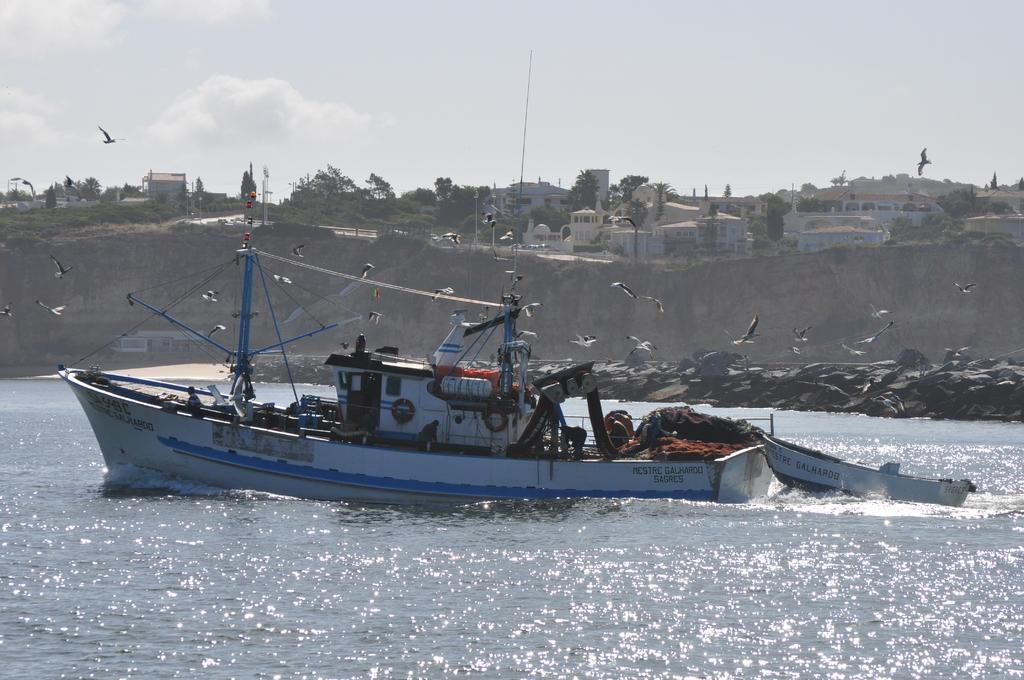Can you describe this image briefly? This image is taken outdoors. At the top of the image there is the sky with clouds. At the bottom of the image there is a sea with water. In the background there is a hill. There are a few trees and plants on the ground. There are many houses and buildings. There are a few poles. Two birds are flying in the sky. In the middle of the image there are many birds flying in the air. There is a boat on the sea. There are many objects in the boat. 